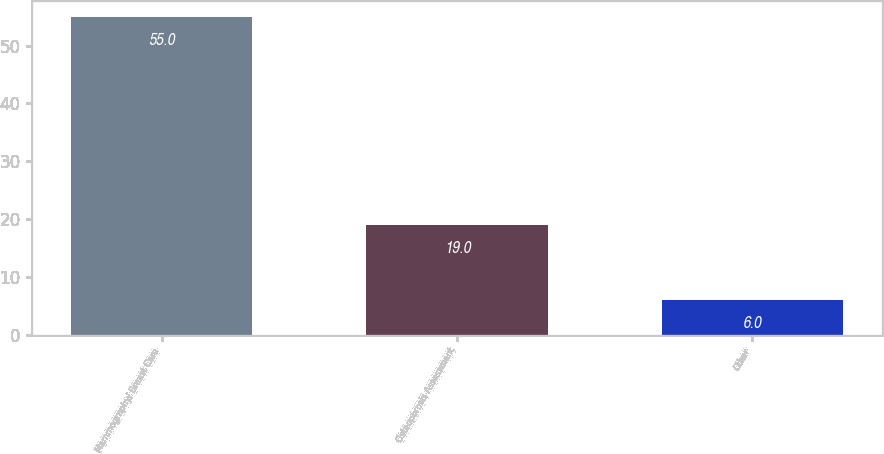<chart> <loc_0><loc_0><loc_500><loc_500><bar_chart><fcel>Mammography/ Breast Care<fcel>Osteoporosis Assessment<fcel>Other<nl><fcel>55<fcel>19<fcel>6<nl></chart> 